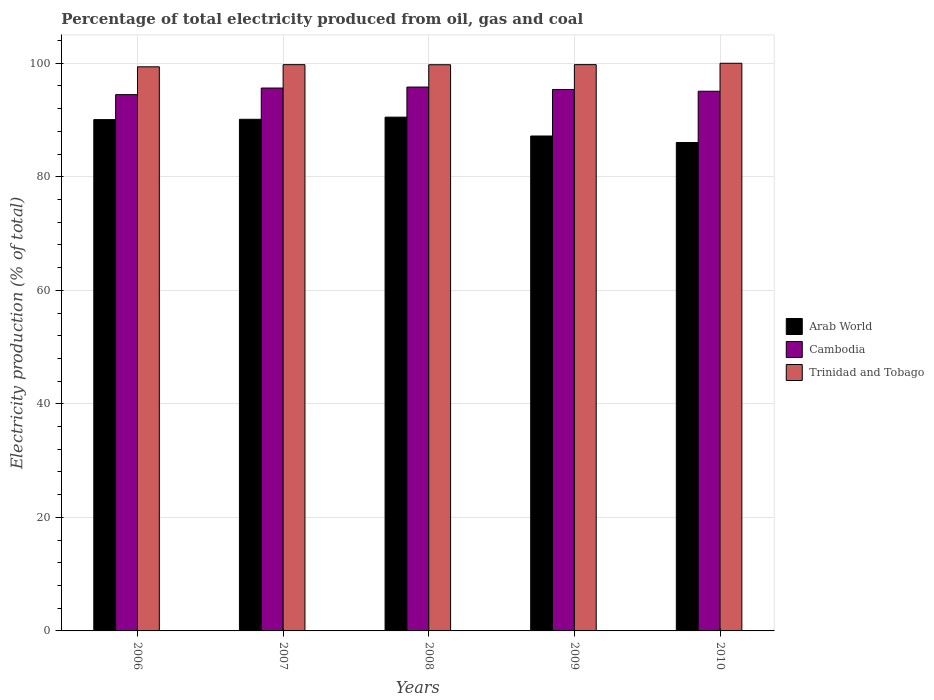How many different coloured bars are there?
Provide a succinct answer. 3. How many groups of bars are there?
Your response must be concise. 5. Are the number of bars on each tick of the X-axis equal?
Your response must be concise. Yes. How many bars are there on the 1st tick from the left?
Make the answer very short. 3. In how many cases, is the number of bars for a given year not equal to the number of legend labels?
Make the answer very short. 0. What is the electricity production in in Trinidad and Tobago in 2009?
Make the answer very short. 99.76. Across all years, what is the maximum electricity production in in Cambodia?
Your answer should be very brief. 95.81. Across all years, what is the minimum electricity production in in Arab World?
Provide a short and direct response. 86.04. In which year was the electricity production in in Arab World maximum?
Offer a very short reply. 2008. What is the total electricity production in in Arab World in the graph?
Provide a succinct answer. 443.93. What is the difference between the electricity production in in Cambodia in 2006 and that in 2008?
Offer a terse response. -1.34. What is the difference between the electricity production in in Trinidad and Tobago in 2007 and the electricity production in in Cambodia in 2006?
Your answer should be compact. 5.28. What is the average electricity production in in Trinidad and Tobago per year?
Your response must be concise. 99.73. In the year 2010, what is the difference between the electricity production in in Arab World and electricity production in in Trinidad and Tobago?
Provide a succinct answer. -13.96. In how many years, is the electricity production in in Arab World greater than 20 %?
Your answer should be very brief. 5. What is the ratio of the electricity production in in Cambodia in 2006 to that in 2009?
Your answer should be compact. 0.99. Is the difference between the electricity production in in Arab World in 2008 and 2010 greater than the difference between the electricity production in in Trinidad and Tobago in 2008 and 2010?
Give a very brief answer. Yes. What is the difference between the highest and the second highest electricity production in in Arab World?
Give a very brief answer. 0.38. What is the difference between the highest and the lowest electricity production in in Arab World?
Offer a very short reply. 4.47. Is the sum of the electricity production in in Arab World in 2008 and 2010 greater than the maximum electricity production in in Trinidad and Tobago across all years?
Ensure brevity in your answer.  Yes. What does the 2nd bar from the left in 2010 represents?
Your answer should be compact. Cambodia. What does the 1st bar from the right in 2007 represents?
Make the answer very short. Trinidad and Tobago. How many bars are there?
Offer a terse response. 15. Are all the bars in the graph horizontal?
Your answer should be compact. No. How many years are there in the graph?
Give a very brief answer. 5. Are the values on the major ticks of Y-axis written in scientific E-notation?
Provide a succinct answer. No. Does the graph contain any zero values?
Give a very brief answer. No. Does the graph contain grids?
Your answer should be very brief. Yes. Where does the legend appear in the graph?
Provide a succinct answer. Center right. How many legend labels are there?
Make the answer very short. 3. How are the legend labels stacked?
Your answer should be very brief. Vertical. What is the title of the graph?
Make the answer very short. Percentage of total electricity produced from oil, gas and coal. Does "Cote d'Ivoire" appear as one of the legend labels in the graph?
Your answer should be compact. No. What is the label or title of the Y-axis?
Your answer should be compact. Electricity production (% of total). What is the Electricity production (% of total) of Arab World in 2006?
Your answer should be compact. 90.07. What is the Electricity production (% of total) in Cambodia in 2006?
Provide a succinct answer. 94.47. What is the Electricity production (% of total) in Trinidad and Tobago in 2006?
Your response must be concise. 99.37. What is the Electricity production (% of total) of Arab World in 2007?
Your answer should be very brief. 90.13. What is the Electricity production (% of total) in Cambodia in 2007?
Provide a succinct answer. 95.63. What is the Electricity production (% of total) of Trinidad and Tobago in 2007?
Make the answer very short. 99.75. What is the Electricity production (% of total) of Arab World in 2008?
Ensure brevity in your answer.  90.51. What is the Electricity production (% of total) of Cambodia in 2008?
Give a very brief answer. 95.81. What is the Electricity production (% of total) of Trinidad and Tobago in 2008?
Ensure brevity in your answer.  99.74. What is the Electricity production (% of total) in Arab World in 2009?
Offer a terse response. 87.18. What is the Electricity production (% of total) in Cambodia in 2009?
Your answer should be compact. 95.38. What is the Electricity production (% of total) in Trinidad and Tobago in 2009?
Keep it short and to the point. 99.76. What is the Electricity production (% of total) in Arab World in 2010?
Offer a terse response. 86.04. What is the Electricity production (% of total) in Cambodia in 2010?
Provide a succinct answer. 95.07. Across all years, what is the maximum Electricity production (% of total) of Arab World?
Offer a very short reply. 90.51. Across all years, what is the maximum Electricity production (% of total) of Cambodia?
Offer a very short reply. 95.81. Across all years, what is the minimum Electricity production (% of total) of Arab World?
Provide a succinct answer. 86.04. Across all years, what is the minimum Electricity production (% of total) in Cambodia?
Your response must be concise. 94.47. Across all years, what is the minimum Electricity production (% of total) of Trinidad and Tobago?
Your response must be concise. 99.37. What is the total Electricity production (% of total) in Arab World in the graph?
Provide a short and direct response. 443.93. What is the total Electricity production (% of total) in Cambodia in the graph?
Provide a succinct answer. 476.37. What is the total Electricity production (% of total) of Trinidad and Tobago in the graph?
Your answer should be very brief. 498.63. What is the difference between the Electricity production (% of total) in Arab World in 2006 and that in 2007?
Provide a succinct answer. -0.06. What is the difference between the Electricity production (% of total) of Cambodia in 2006 and that in 2007?
Your response must be concise. -1.16. What is the difference between the Electricity production (% of total) in Trinidad and Tobago in 2006 and that in 2007?
Provide a short and direct response. -0.38. What is the difference between the Electricity production (% of total) in Arab World in 2006 and that in 2008?
Keep it short and to the point. -0.43. What is the difference between the Electricity production (% of total) of Cambodia in 2006 and that in 2008?
Provide a succinct answer. -1.34. What is the difference between the Electricity production (% of total) in Trinidad and Tobago in 2006 and that in 2008?
Give a very brief answer. -0.37. What is the difference between the Electricity production (% of total) in Arab World in 2006 and that in 2009?
Offer a very short reply. 2.89. What is the difference between the Electricity production (% of total) of Cambodia in 2006 and that in 2009?
Provide a succinct answer. -0.91. What is the difference between the Electricity production (% of total) of Trinidad and Tobago in 2006 and that in 2009?
Ensure brevity in your answer.  -0.38. What is the difference between the Electricity production (% of total) in Arab World in 2006 and that in 2010?
Your answer should be compact. 4.04. What is the difference between the Electricity production (% of total) in Cambodia in 2006 and that in 2010?
Provide a short and direct response. -0.6. What is the difference between the Electricity production (% of total) in Trinidad and Tobago in 2006 and that in 2010?
Your answer should be very brief. -0.63. What is the difference between the Electricity production (% of total) of Arab World in 2007 and that in 2008?
Your response must be concise. -0.38. What is the difference between the Electricity production (% of total) in Cambodia in 2007 and that in 2008?
Make the answer very short. -0.17. What is the difference between the Electricity production (% of total) of Trinidad and Tobago in 2007 and that in 2008?
Provide a short and direct response. 0.01. What is the difference between the Electricity production (% of total) in Arab World in 2007 and that in 2009?
Make the answer very short. 2.95. What is the difference between the Electricity production (% of total) in Cambodia in 2007 and that in 2009?
Ensure brevity in your answer.  0.25. What is the difference between the Electricity production (% of total) of Trinidad and Tobago in 2007 and that in 2009?
Your response must be concise. -0.01. What is the difference between the Electricity production (% of total) in Arab World in 2007 and that in 2010?
Offer a terse response. 4.09. What is the difference between the Electricity production (% of total) in Cambodia in 2007 and that in 2010?
Make the answer very short. 0.56. What is the difference between the Electricity production (% of total) in Trinidad and Tobago in 2007 and that in 2010?
Offer a terse response. -0.25. What is the difference between the Electricity production (% of total) of Arab World in 2008 and that in 2009?
Your answer should be very brief. 3.32. What is the difference between the Electricity production (% of total) in Cambodia in 2008 and that in 2009?
Ensure brevity in your answer.  0.43. What is the difference between the Electricity production (% of total) in Trinidad and Tobago in 2008 and that in 2009?
Provide a short and direct response. -0.02. What is the difference between the Electricity production (% of total) in Arab World in 2008 and that in 2010?
Provide a short and direct response. 4.47. What is the difference between the Electricity production (% of total) in Cambodia in 2008 and that in 2010?
Offer a very short reply. 0.74. What is the difference between the Electricity production (% of total) in Trinidad and Tobago in 2008 and that in 2010?
Offer a terse response. -0.26. What is the difference between the Electricity production (% of total) in Arab World in 2009 and that in 2010?
Offer a very short reply. 1.14. What is the difference between the Electricity production (% of total) of Cambodia in 2009 and that in 2010?
Your answer should be compact. 0.31. What is the difference between the Electricity production (% of total) of Trinidad and Tobago in 2009 and that in 2010?
Keep it short and to the point. -0.24. What is the difference between the Electricity production (% of total) of Arab World in 2006 and the Electricity production (% of total) of Cambodia in 2007?
Your response must be concise. -5.56. What is the difference between the Electricity production (% of total) of Arab World in 2006 and the Electricity production (% of total) of Trinidad and Tobago in 2007?
Provide a succinct answer. -9.68. What is the difference between the Electricity production (% of total) in Cambodia in 2006 and the Electricity production (% of total) in Trinidad and Tobago in 2007?
Give a very brief answer. -5.28. What is the difference between the Electricity production (% of total) of Arab World in 2006 and the Electricity production (% of total) of Cambodia in 2008?
Give a very brief answer. -5.73. What is the difference between the Electricity production (% of total) in Arab World in 2006 and the Electricity production (% of total) in Trinidad and Tobago in 2008?
Offer a very short reply. -9.67. What is the difference between the Electricity production (% of total) of Cambodia in 2006 and the Electricity production (% of total) of Trinidad and Tobago in 2008?
Your answer should be very brief. -5.27. What is the difference between the Electricity production (% of total) of Arab World in 2006 and the Electricity production (% of total) of Cambodia in 2009?
Offer a very short reply. -5.31. What is the difference between the Electricity production (% of total) in Arab World in 2006 and the Electricity production (% of total) in Trinidad and Tobago in 2009?
Offer a terse response. -9.68. What is the difference between the Electricity production (% of total) of Cambodia in 2006 and the Electricity production (% of total) of Trinidad and Tobago in 2009?
Make the answer very short. -5.29. What is the difference between the Electricity production (% of total) in Arab World in 2006 and the Electricity production (% of total) in Cambodia in 2010?
Your answer should be very brief. -5. What is the difference between the Electricity production (% of total) of Arab World in 2006 and the Electricity production (% of total) of Trinidad and Tobago in 2010?
Ensure brevity in your answer.  -9.93. What is the difference between the Electricity production (% of total) in Cambodia in 2006 and the Electricity production (% of total) in Trinidad and Tobago in 2010?
Keep it short and to the point. -5.53. What is the difference between the Electricity production (% of total) of Arab World in 2007 and the Electricity production (% of total) of Cambodia in 2008?
Your answer should be very brief. -5.68. What is the difference between the Electricity production (% of total) in Arab World in 2007 and the Electricity production (% of total) in Trinidad and Tobago in 2008?
Keep it short and to the point. -9.61. What is the difference between the Electricity production (% of total) in Cambodia in 2007 and the Electricity production (% of total) in Trinidad and Tobago in 2008?
Your response must be concise. -4.11. What is the difference between the Electricity production (% of total) in Arab World in 2007 and the Electricity production (% of total) in Cambodia in 2009?
Offer a terse response. -5.25. What is the difference between the Electricity production (% of total) in Arab World in 2007 and the Electricity production (% of total) in Trinidad and Tobago in 2009?
Your answer should be very brief. -9.63. What is the difference between the Electricity production (% of total) in Cambodia in 2007 and the Electricity production (% of total) in Trinidad and Tobago in 2009?
Keep it short and to the point. -4.12. What is the difference between the Electricity production (% of total) in Arab World in 2007 and the Electricity production (% of total) in Cambodia in 2010?
Your answer should be very brief. -4.94. What is the difference between the Electricity production (% of total) of Arab World in 2007 and the Electricity production (% of total) of Trinidad and Tobago in 2010?
Keep it short and to the point. -9.87. What is the difference between the Electricity production (% of total) of Cambodia in 2007 and the Electricity production (% of total) of Trinidad and Tobago in 2010?
Offer a terse response. -4.37. What is the difference between the Electricity production (% of total) of Arab World in 2008 and the Electricity production (% of total) of Cambodia in 2009?
Provide a short and direct response. -4.88. What is the difference between the Electricity production (% of total) in Arab World in 2008 and the Electricity production (% of total) in Trinidad and Tobago in 2009?
Keep it short and to the point. -9.25. What is the difference between the Electricity production (% of total) in Cambodia in 2008 and the Electricity production (% of total) in Trinidad and Tobago in 2009?
Your answer should be very brief. -3.95. What is the difference between the Electricity production (% of total) of Arab World in 2008 and the Electricity production (% of total) of Cambodia in 2010?
Your answer should be compact. -4.56. What is the difference between the Electricity production (% of total) of Arab World in 2008 and the Electricity production (% of total) of Trinidad and Tobago in 2010?
Keep it short and to the point. -9.49. What is the difference between the Electricity production (% of total) of Cambodia in 2008 and the Electricity production (% of total) of Trinidad and Tobago in 2010?
Keep it short and to the point. -4.19. What is the difference between the Electricity production (% of total) of Arab World in 2009 and the Electricity production (% of total) of Cambodia in 2010?
Ensure brevity in your answer.  -7.89. What is the difference between the Electricity production (% of total) of Arab World in 2009 and the Electricity production (% of total) of Trinidad and Tobago in 2010?
Make the answer very short. -12.82. What is the difference between the Electricity production (% of total) in Cambodia in 2009 and the Electricity production (% of total) in Trinidad and Tobago in 2010?
Your answer should be compact. -4.62. What is the average Electricity production (% of total) of Arab World per year?
Keep it short and to the point. 88.79. What is the average Electricity production (% of total) in Cambodia per year?
Keep it short and to the point. 95.27. What is the average Electricity production (% of total) of Trinidad and Tobago per year?
Provide a succinct answer. 99.73. In the year 2006, what is the difference between the Electricity production (% of total) in Arab World and Electricity production (% of total) in Cambodia?
Offer a very short reply. -4.4. In the year 2006, what is the difference between the Electricity production (% of total) in Arab World and Electricity production (% of total) in Trinidad and Tobago?
Make the answer very short. -9.3. In the year 2006, what is the difference between the Electricity production (% of total) of Cambodia and Electricity production (% of total) of Trinidad and Tobago?
Your answer should be compact. -4.9. In the year 2007, what is the difference between the Electricity production (% of total) of Arab World and Electricity production (% of total) of Cambodia?
Your response must be concise. -5.51. In the year 2007, what is the difference between the Electricity production (% of total) of Arab World and Electricity production (% of total) of Trinidad and Tobago?
Your response must be concise. -9.62. In the year 2007, what is the difference between the Electricity production (% of total) in Cambodia and Electricity production (% of total) in Trinidad and Tobago?
Your answer should be compact. -4.12. In the year 2008, what is the difference between the Electricity production (% of total) of Arab World and Electricity production (% of total) of Cambodia?
Offer a very short reply. -5.3. In the year 2008, what is the difference between the Electricity production (% of total) of Arab World and Electricity production (% of total) of Trinidad and Tobago?
Ensure brevity in your answer.  -9.24. In the year 2008, what is the difference between the Electricity production (% of total) of Cambodia and Electricity production (% of total) of Trinidad and Tobago?
Offer a terse response. -3.93. In the year 2009, what is the difference between the Electricity production (% of total) of Arab World and Electricity production (% of total) of Cambodia?
Offer a terse response. -8.2. In the year 2009, what is the difference between the Electricity production (% of total) in Arab World and Electricity production (% of total) in Trinidad and Tobago?
Your answer should be very brief. -12.57. In the year 2009, what is the difference between the Electricity production (% of total) of Cambodia and Electricity production (% of total) of Trinidad and Tobago?
Keep it short and to the point. -4.38. In the year 2010, what is the difference between the Electricity production (% of total) in Arab World and Electricity production (% of total) in Cambodia?
Give a very brief answer. -9.03. In the year 2010, what is the difference between the Electricity production (% of total) in Arab World and Electricity production (% of total) in Trinidad and Tobago?
Offer a terse response. -13.96. In the year 2010, what is the difference between the Electricity production (% of total) of Cambodia and Electricity production (% of total) of Trinidad and Tobago?
Offer a terse response. -4.93. What is the ratio of the Electricity production (% of total) of Arab World in 2006 to that in 2007?
Keep it short and to the point. 1. What is the ratio of the Electricity production (% of total) of Cambodia in 2006 to that in 2007?
Your answer should be compact. 0.99. What is the ratio of the Electricity production (% of total) of Trinidad and Tobago in 2006 to that in 2007?
Offer a terse response. 1. What is the ratio of the Electricity production (% of total) in Arab World in 2006 to that in 2008?
Give a very brief answer. 1. What is the ratio of the Electricity production (% of total) in Cambodia in 2006 to that in 2008?
Offer a very short reply. 0.99. What is the ratio of the Electricity production (% of total) of Trinidad and Tobago in 2006 to that in 2008?
Your answer should be compact. 1. What is the ratio of the Electricity production (% of total) in Arab World in 2006 to that in 2009?
Offer a terse response. 1.03. What is the ratio of the Electricity production (% of total) of Arab World in 2006 to that in 2010?
Provide a succinct answer. 1.05. What is the ratio of the Electricity production (% of total) in Cambodia in 2007 to that in 2008?
Provide a succinct answer. 1. What is the ratio of the Electricity production (% of total) in Arab World in 2007 to that in 2009?
Your answer should be very brief. 1.03. What is the ratio of the Electricity production (% of total) of Cambodia in 2007 to that in 2009?
Provide a succinct answer. 1. What is the ratio of the Electricity production (% of total) of Trinidad and Tobago in 2007 to that in 2009?
Offer a very short reply. 1. What is the ratio of the Electricity production (% of total) in Arab World in 2007 to that in 2010?
Your answer should be compact. 1.05. What is the ratio of the Electricity production (% of total) of Cambodia in 2007 to that in 2010?
Your answer should be compact. 1.01. What is the ratio of the Electricity production (% of total) of Arab World in 2008 to that in 2009?
Ensure brevity in your answer.  1.04. What is the ratio of the Electricity production (% of total) of Trinidad and Tobago in 2008 to that in 2009?
Keep it short and to the point. 1. What is the ratio of the Electricity production (% of total) in Arab World in 2008 to that in 2010?
Ensure brevity in your answer.  1.05. What is the ratio of the Electricity production (% of total) of Arab World in 2009 to that in 2010?
Give a very brief answer. 1.01. What is the difference between the highest and the second highest Electricity production (% of total) of Arab World?
Provide a short and direct response. 0.38. What is the difference between the highest and the second highest Electricity production (% of total) of Cambodia?
Your response must be concise. 0.17. What is the difference between the highest and the second highest Electricity production (% of total) of Trinidad and Tobago?
Provide a short and direct response. 0.24. What is the difference between the highest and the lowest Electricity production (% of total) in Arab World?
Your answer should be compact. 4.47. What is the difference between the highest and the lowest Electricity production (% of total) of Cambodia?
Make the answer very short. 1.34. What is the difference between the highest and the lowest Electricity production (% of total) of Trinidad and Tobago?
Provide a short and direct response. 0.63. 